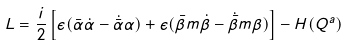Convert formula to latex. <formula><loc_0><loc_0><loc_500><loc_500>L = \frac { i } { 2 } \left [ \epsilon ( { \bar { \alpha } } \dot { \alpha } - \dot { \bar { \alpha } } \alpha ) + \epsilon ( { \bar { \beta } } m \dot { \beta } - \dot { \bar { \beta } } m \beta ) \right ] - H ( Q ^ { a } )</formula> 